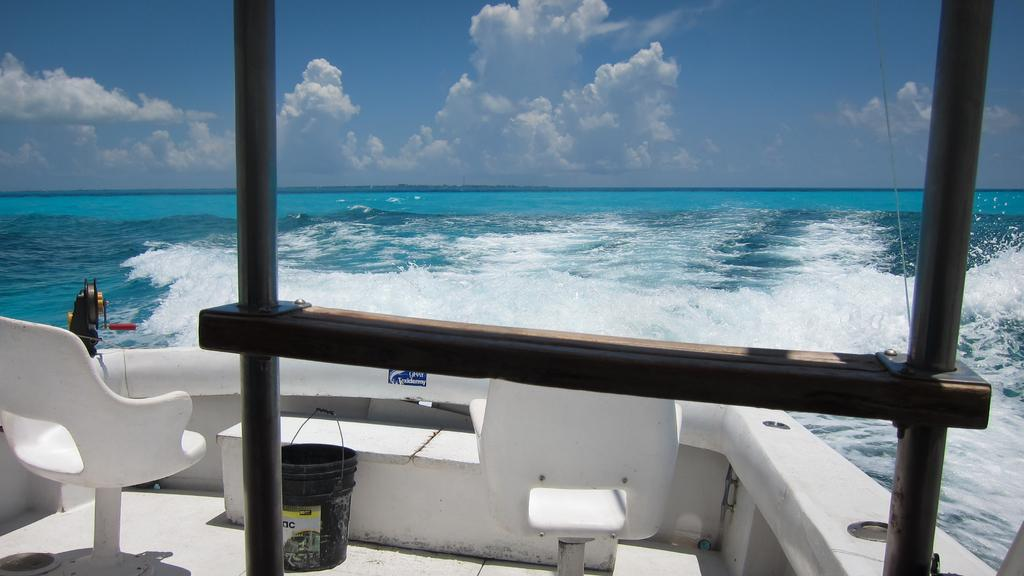What type of furniture is present in the image? There are chairs in the image. What object can be seen that is typically used for holding or carrying items? There is a bucket in the image. What vertical structures are visible in the image? There are poles in the image. What type of decoration or label is present in the image? There is a sticker in the image. What natural feature can be seen in the background of the image? The background of the image includes the sea. How would you describe the sky in the image? The sky is visible at the top of the image and appears to be cloudy. What type of letter is being delivered by the industry in the image? There is no industry or letter present in the image. How does the earth interact with the objects in the image? The earth is not an active participant in the image; it is the ground on which the objects are placed. 